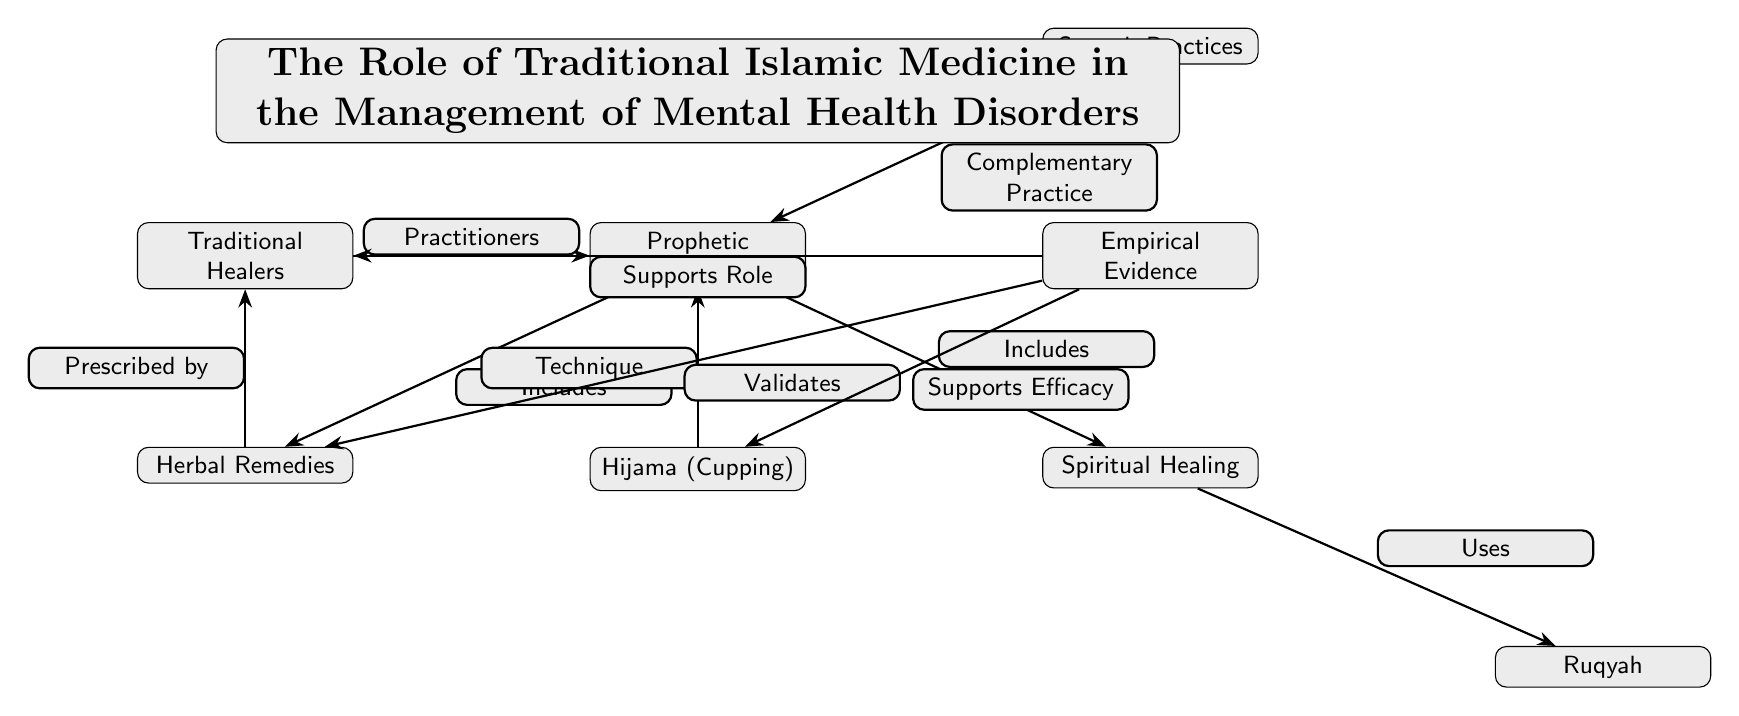What is at the center of the diagram? The central node represents "Prophetic Medicine," which signifies its foundational role in the management of mental health disorders as illustrated in the diagram.
Answer: Prophetic Medicine How many main components are connected to Prophetic Medicine? The diagram shows five main components connected to "Prophetic Medicine": Herbal Remedies, Spiritual Healing, Sunnah Practices, Traditional Healers, and Hijama. Therefore, the total is five components.
Answer: 5 What type of practice is Hijama classified as? In the diagram, Hijama is described as a "Technique," indicating its methodological approach within the realm of Prophetic Medicine for managing mental health disorders.
Answer: Technique Which node represents a complementary practice to Prophetic Medicine? The node labeled "Sunnah Practices" is indicated as a "Complementary Practice," highlighting its supporting role alongside Prophetic Medicine in the treatment process for mental health disorders.
Answer: Sunnah Practices What two components does Spiritual Healing utilize? The "Spiritual Healing" node points to "Ruqyah" as a direct utilization, which suggests that Ruqyah is a specific method derived from the broader category of Spiritual Healing within the context of mental health management.
Answer: Ruqyah What supports the efficacy of Hijama according to the diagram? "Empirical Evidence" provides support for the efficacy of Hijama, establishing the connection that empirical observations affirm Hijama's usefulness in traditional Islamic medicine.
Answer: Empirical Evidence How are Traditional Healers related to Herbal Remedies? The arrow indicates that Herbal Remedies are "Prescribed by" Traditional Healers, establishing a direct relationship where Traditional Healers administer these remedies in practice.
Answer: Prescribed by In what way does Empirical Evidence validate Herbal Remedies? The diagram establishes that empirical evidence "Validates" Herbal Remedies, thus indicating that scientific or practical observations support the effectiveness of these remedies as part of traditional Islamic medicine for mental health disorders.
Answer: Validates How is Ruqyah related to Spiritual Healing? The diagram explicitly states that Spiritual Healing "Uses" Ruqyah, which suggests that Ruqyah is a vital method applied within the broader practices of Spiritual Healing.
Answer: Uses 